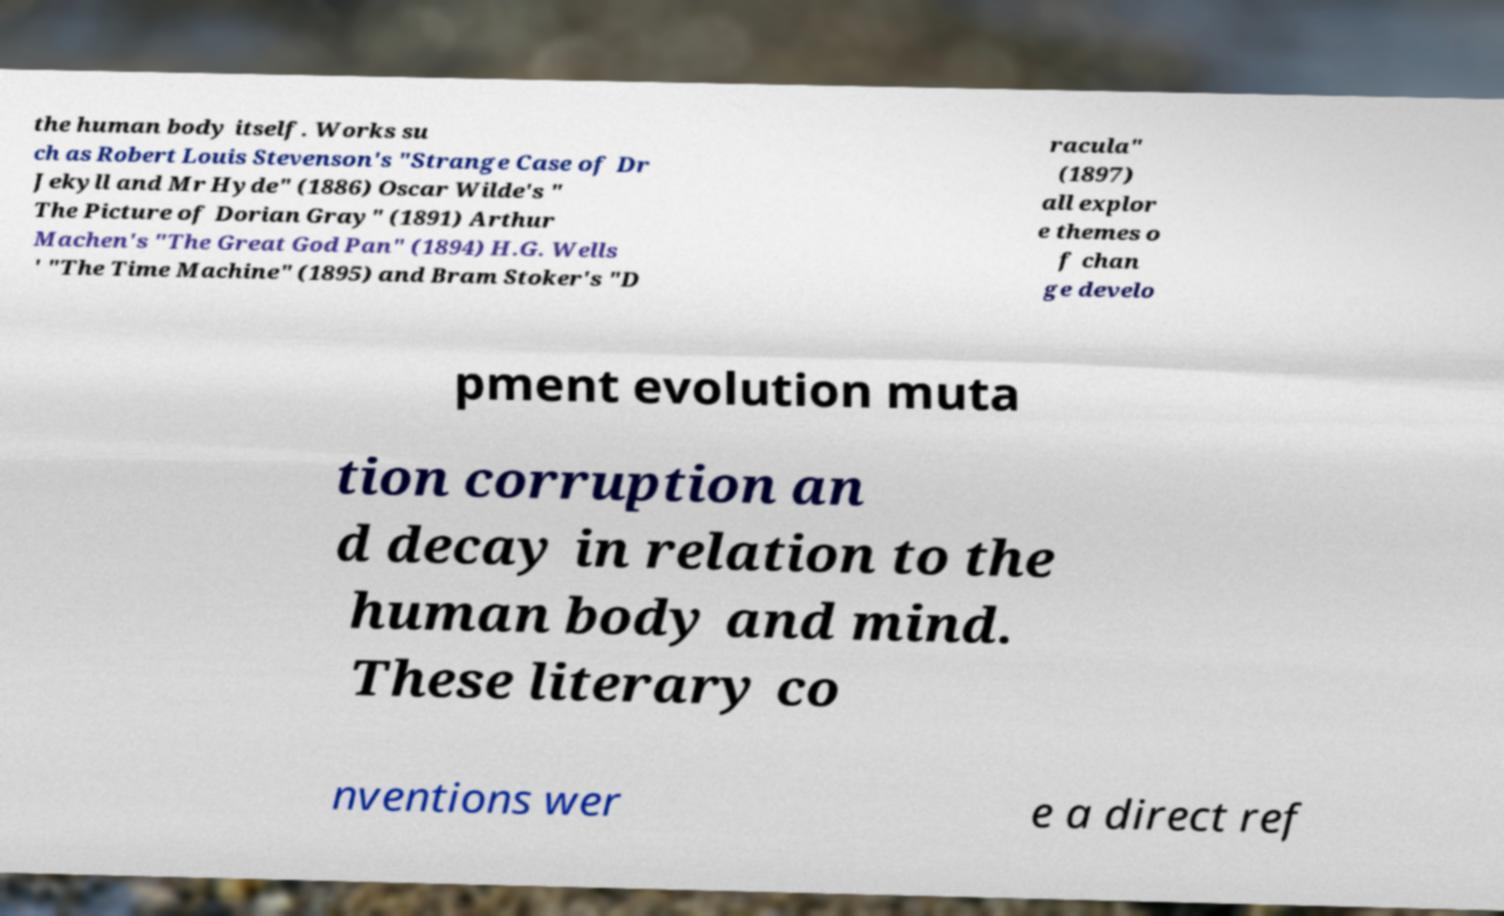There's text embedded in this image that I need extracted. Can you transcribe it verbatim? the human body itself. Works su ch as Robert Louis Stevenson's "Strange Case of Dr Jekyll and Mr Hyde" (1886) Oscar Wilde's " The Picture of Dorian Gray" (1891) Arthur Machen's "The Great God Pan" (1894) H.G. Wells ' "The Time Machine" (1895) and Bram Stoker's "D racula" (1897) all explor e themes o f chan ge develo pment evolution muta tion corruption an d decay in relation to the human body and mind. These literary co nventions wer e a direct ref 